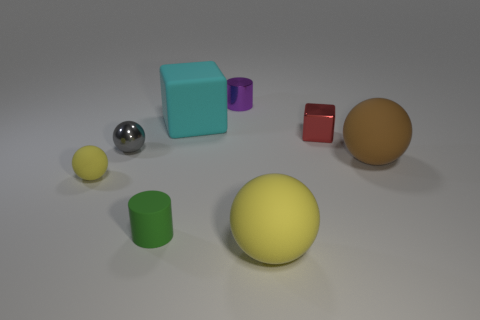What is the material of the big brown object?
Offer a terse response. Rubber. Do the small rubber ball and the big rubber sphere that is left of the tiny red thing have the same color?
Provide a succinct answer. Yes. Are there any other things that are the same size as the brown matte object?
Offer a very short reply. Yes. How big is the metal object that is both left of the small red block and on the right side of the tiny gray object?
Keep it short and to the point. Small. There is a big yellow thing that is made of the same material as the cyan block; what is its shape?
Provide a succinct answer. Sphere. Are the tiny gray thing and the small thing that is behind the metallic cube made of the same material?
Your answer should be compact. Yes. There is a tiny cylinder that is left of the big cyan block; are there any tiny green rubber cylinders behind it?
Keep it short and to the point. No. There is a brown object that is the same shape as the large yellow object; what material is it?
Give a very brief answer. Rubber. How many tiny matte spheres are in front of the cylinder behind the big brown thing?
Your answer should be very brief. 1. Are there any other things that have the same color as the small matte sphere?
Keep it short and to the point. Yes. 